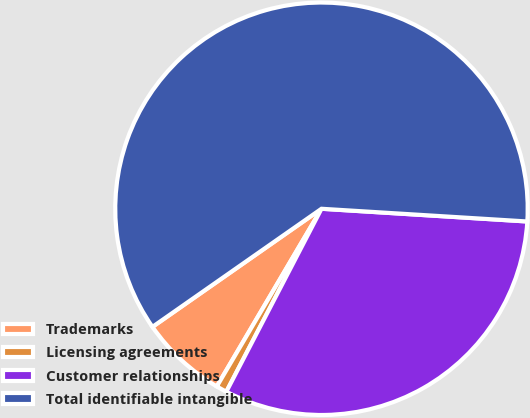Convert chart. <chart><loc_0><loc_0><loc_500><loc_500><pie_chart><fcel>Trademarks<fcel>Licensing agreements<fcel>Customer relationships<fcel>Total identifiable intangible<nl><fcel>6.82%<fcel>0.84%<fcel>31.65%<fcel>60.69%<nl></chart> 